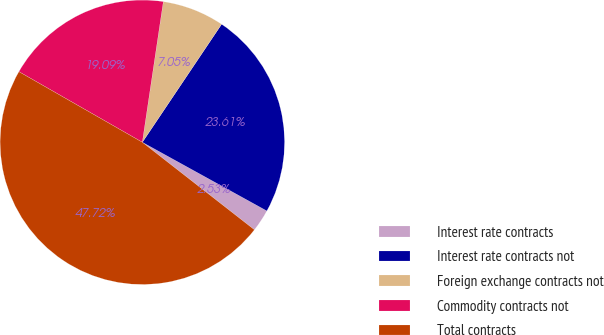<chart> <loc_0><loc_0><loc_500><loc_500><pie_chart><fcel>Interest rate contracts<fcel>Interest rate contracts not<fcel>Foreign exchange contracts not<fcel>Commodity contracts not<fcel>Total contracts<nl><fcel>2.53%<fcel>23.61%<fcel>7.05%<fcel>19.09%<fcel>47.72%<nl></chart> 